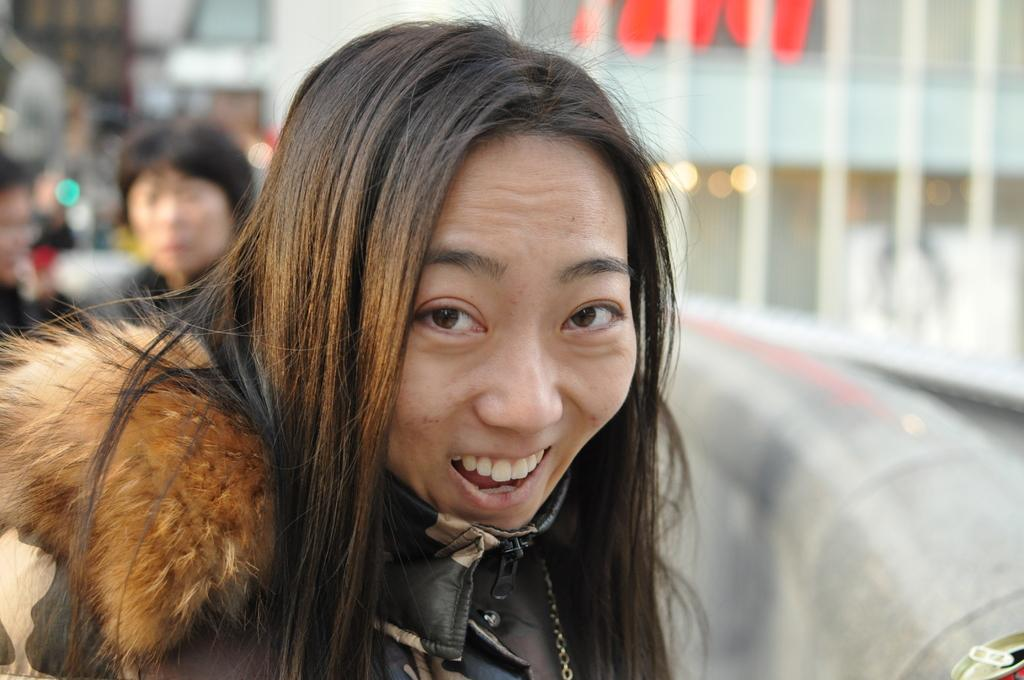Who are the people in the image? There is a woman and a man in the image. Can you describe the relationship between the two people? The facts provided do not give any information about the relationship between the woman and the man. What are the people in the image doing? The facts provided do not give any information about what the woman and the man are doing. What type of leaf is being used as a currency in the image? There is no leaf present in the image, and therefore no such currency can be observed. 